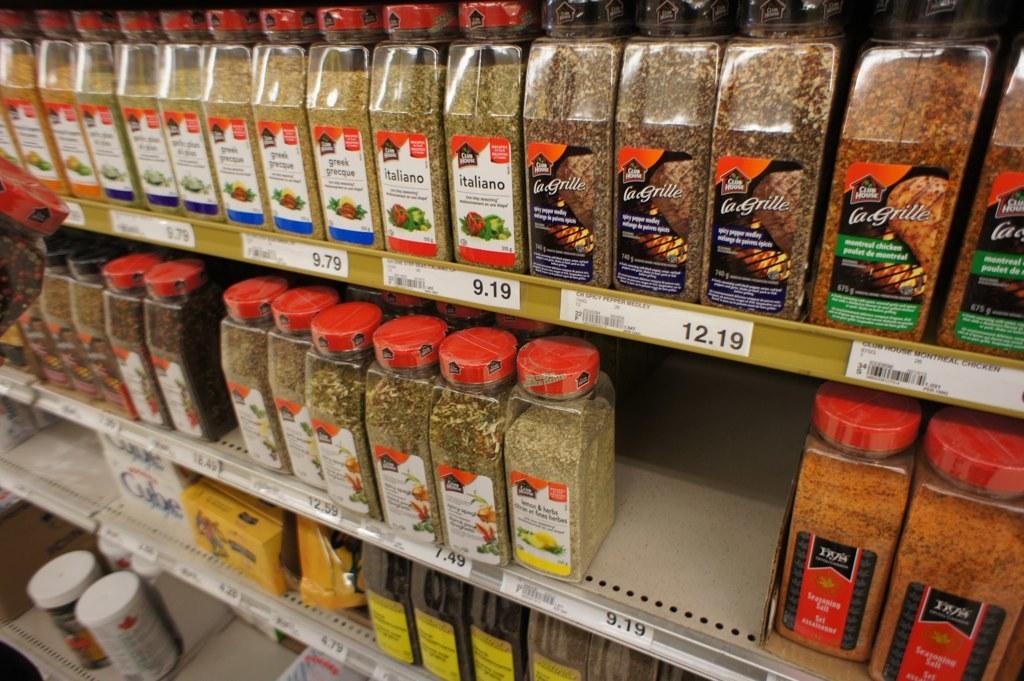What kind of herbs is 9.19?
Keep it short and to the point. Italiano. What product is being sold?
Make the answer very short. Seasoning. 